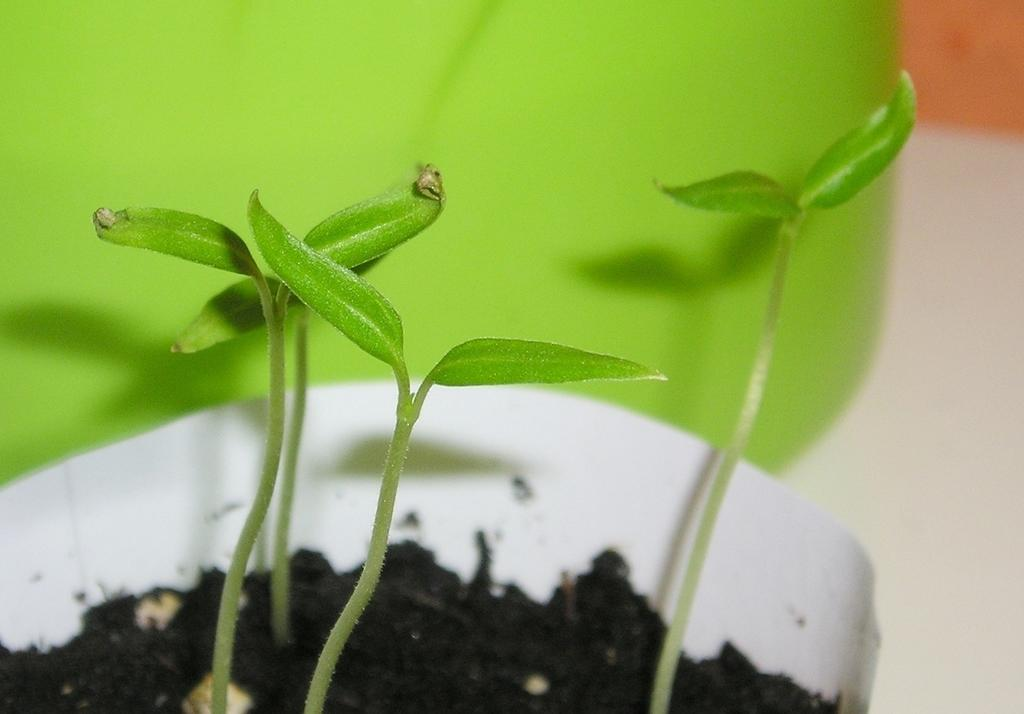What type of plants are in the image? There are plants in a pot in the image. What color is the pot? The pot is white in color. Where is the pot located? The pot is placed on the floor. What can be seen beside the pot? There is a green color object beside the pot. What type of plastic material is used to make the lead in the image? There is no plastic or lead present in the image. The image features plants in a white pot, with a green color object beside it. 